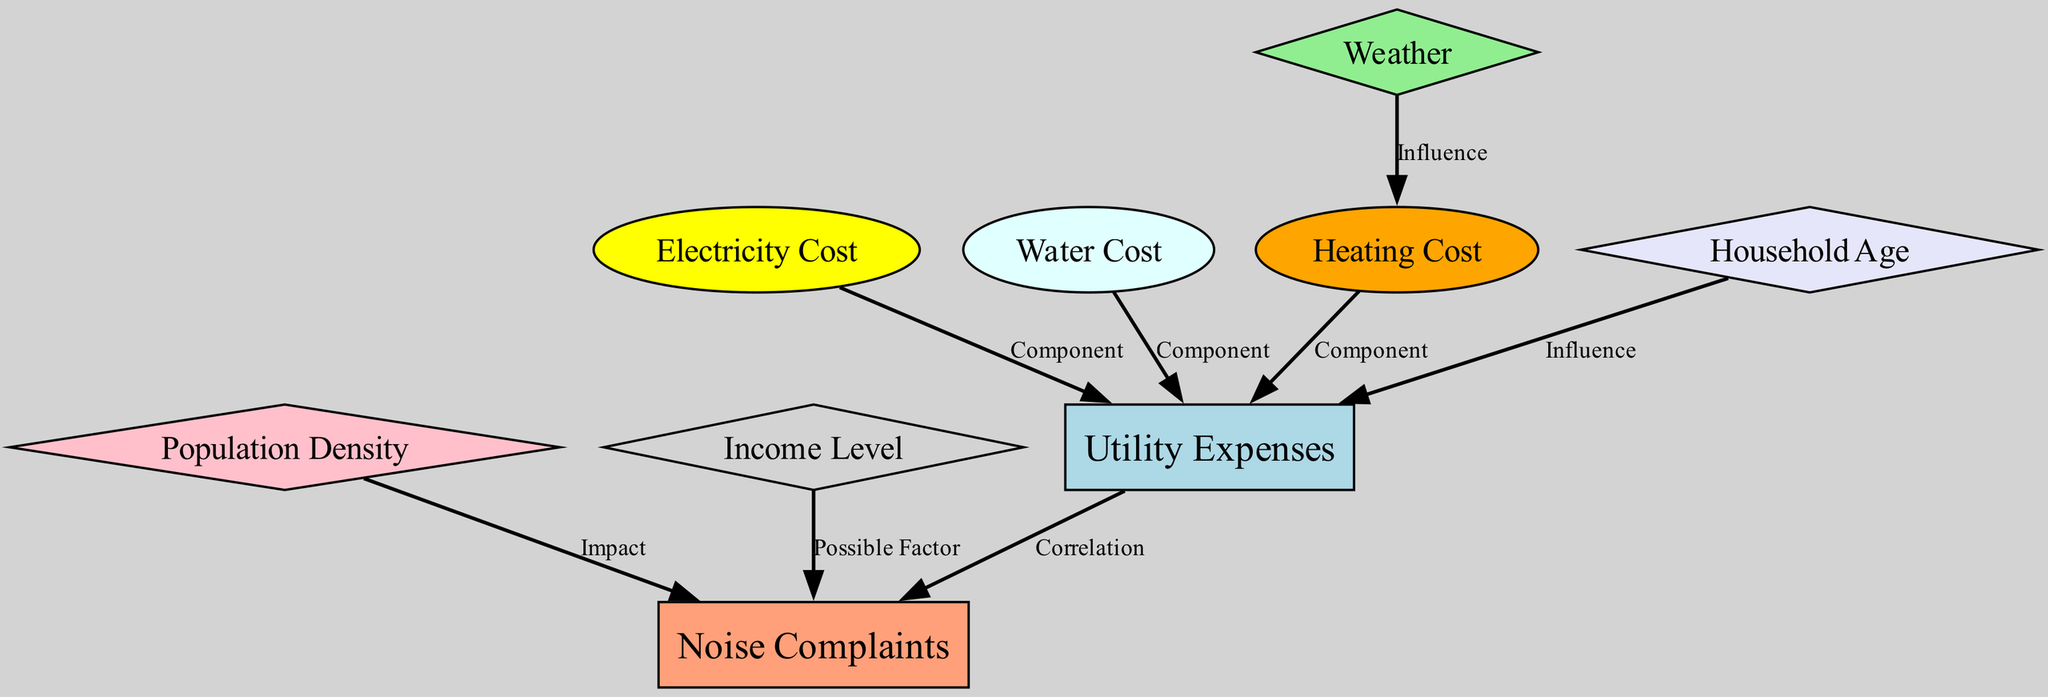what is the total number of nodes in the diagram? The diagram lists nine distinct nodes that represent different aspects related to utility expenses and noise complaints.
Answer: 9 what is the relationship between Utility Expenses and Noise Complaints? The diagram indicates a direct correlation between Utility Expenses and Noise Complaints, emphasizing how higher utility costs may relate to more noise disturbances reported.
Answer: Correlation which component contributes to Utility Expenses in the diagram? The diagram shows three components: Electricity Cost, Water Cost, and Heating Cost, all of which are categorized under Utility Expenses.
Answer: Electricity Cost, Water Cost, Heating Cost how does Weather affect Heating Cost according to the diagram? The diagram notes that Weather influences Heating Cost, suggesting that variations in weather conditions can lead to changes in heating expenses.
Answer: Influence what is the impact of Population Density on Noise Complaints? According to the diagram, increased Population Density can lead to a higher number of reported Noise Complaints, indicating a relationship between these two variables.
Answer: Impact how does Household Age relate to Utility Expenses? The diagram shows that Household Age influences Utility Expenses, suggesting that older buildings may incur higher costs due to inefficiencies or outdated systems.
Answer: Influence is there any correlation between Income Level and Noise Complaints? Yes, the diagram indicates that Income Level is a possible factor influencing the number of Noise Complaints made by residents in the area.
Answer: Possible Factor what color represents Utility Expenses in the diagram? The diagram uses light blue to represent Utility Expenses, which is visually distinct within the chart's overall color scheme.
Answer: Light Blue which edge connects Noise Complaints to Population Density? The diagram does not directly connect Noise Complaints to Population Density; instead, it highlights how Population Density impacts Noise Complaints indirectly through a marked influence.
Answer: Impact 